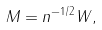Convert formula to latex. <formula><loc_0><loc_0><loc_500><loc_500>M = n ^ { - 1 / 2 } W ,</formula> 